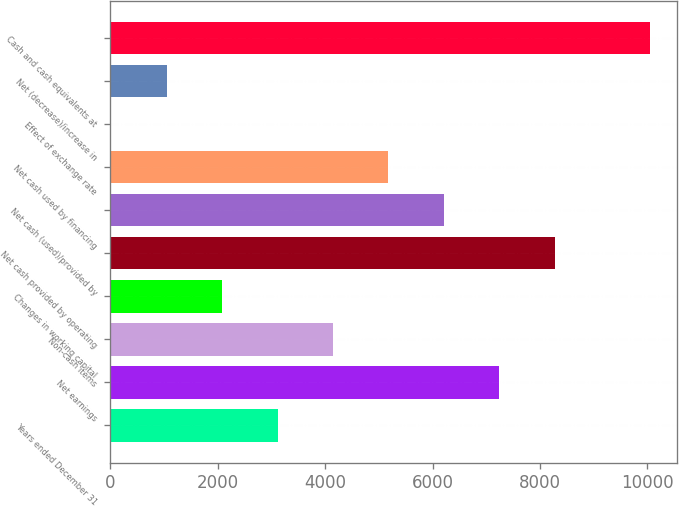Convert chart to OTSL. <chart><loc_0><loc_0><loc_500><loc_500><bar_chart><fcel>Years ended December 31<fcel>Net earnings<fcel>Non-cash items<fcel>Changes in working capital<fcel>Net cash provided by operating<fcel>Net cash (used)/provided by<fcel>Net cash used by financing<fcel>Effect of exchange rate<fcel>Net (decrease)/increase in<fcel>Cash and cash equivalents at<nl><fcel>3114.9<fcel>7244.1<fcel>4147.2<fcel>2082.6<fcel>8276.4<fcel>6211.8<fcel>5179.5<fcel>18<fcel>1050.3<fcel>10049<nl></chart> 